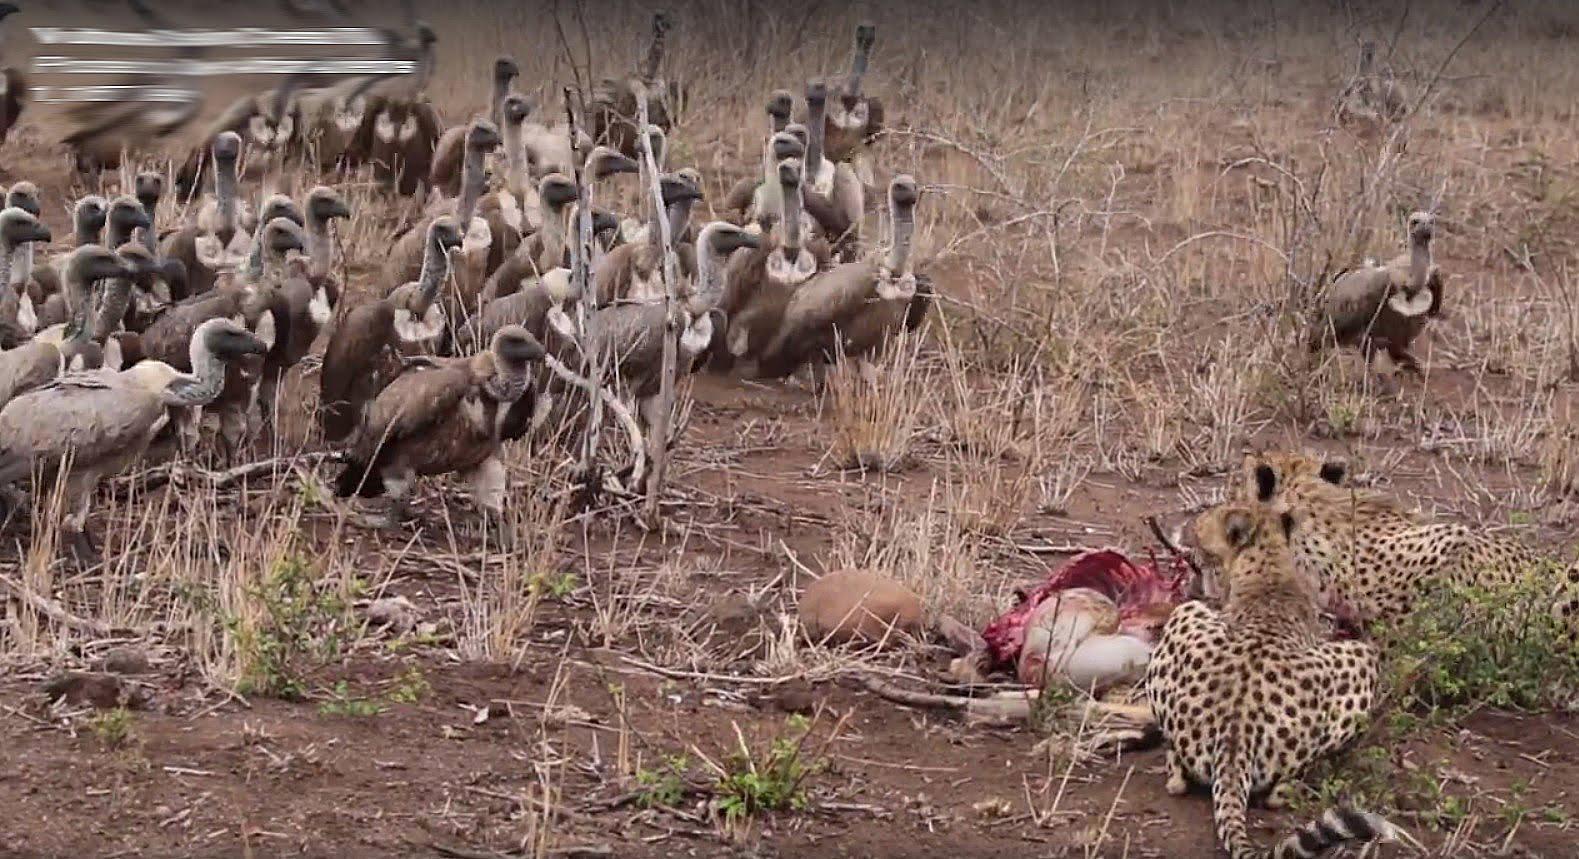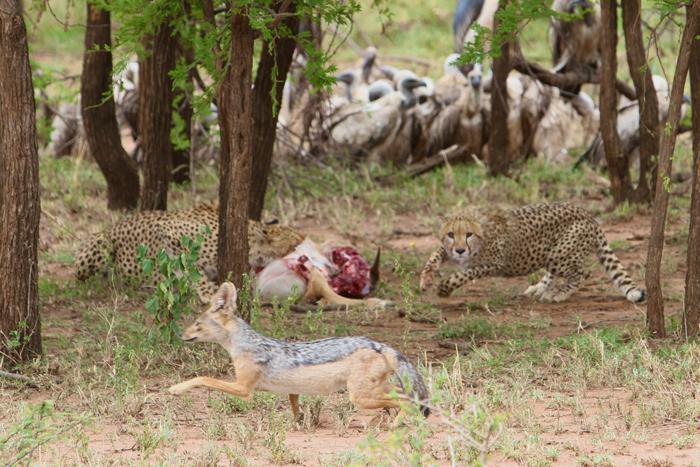The first image is the image on the left, the second image is the image on the right. Given the left and right images, does the statement "There are a total of two hyena in the images." hold true? Answer yes or no. No. The first image is the image on the left, the second image is the image on the right. Analyze the images presented: Is the assertion "there is at least one hyena in the image on the left" valid? Answer yes or no. No. 